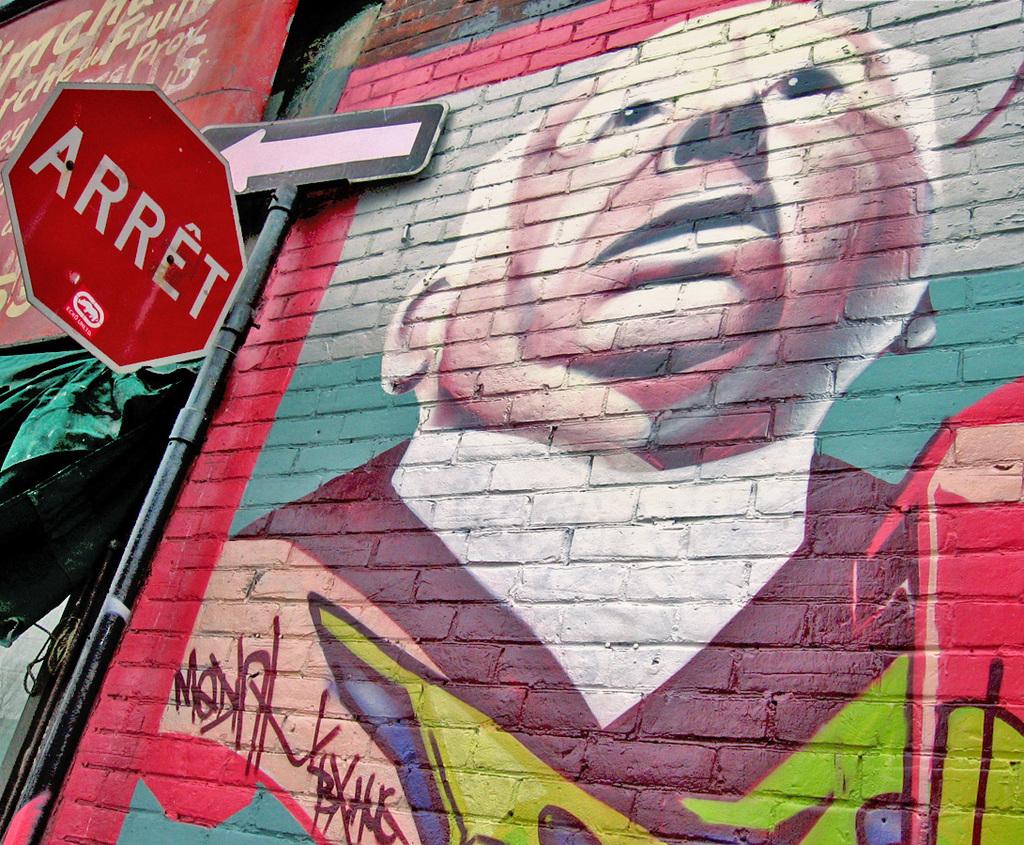What does the sign say?
Your response must be concise. Arret. 